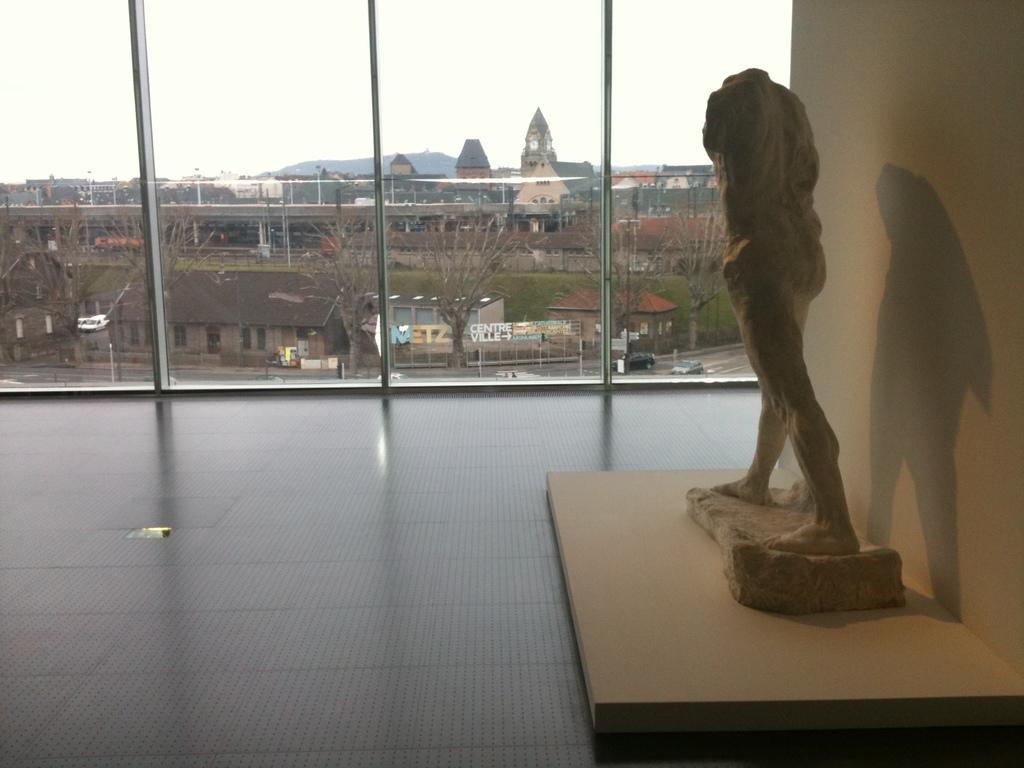How would you summarize this image in a sentence or two? On the right side of the image there is a statue. Behind the statue there is a wall. In the background of the image there are glass windows through which we can see trees, buildings, cars, boards, mountains. At the top of the image there is sky. 